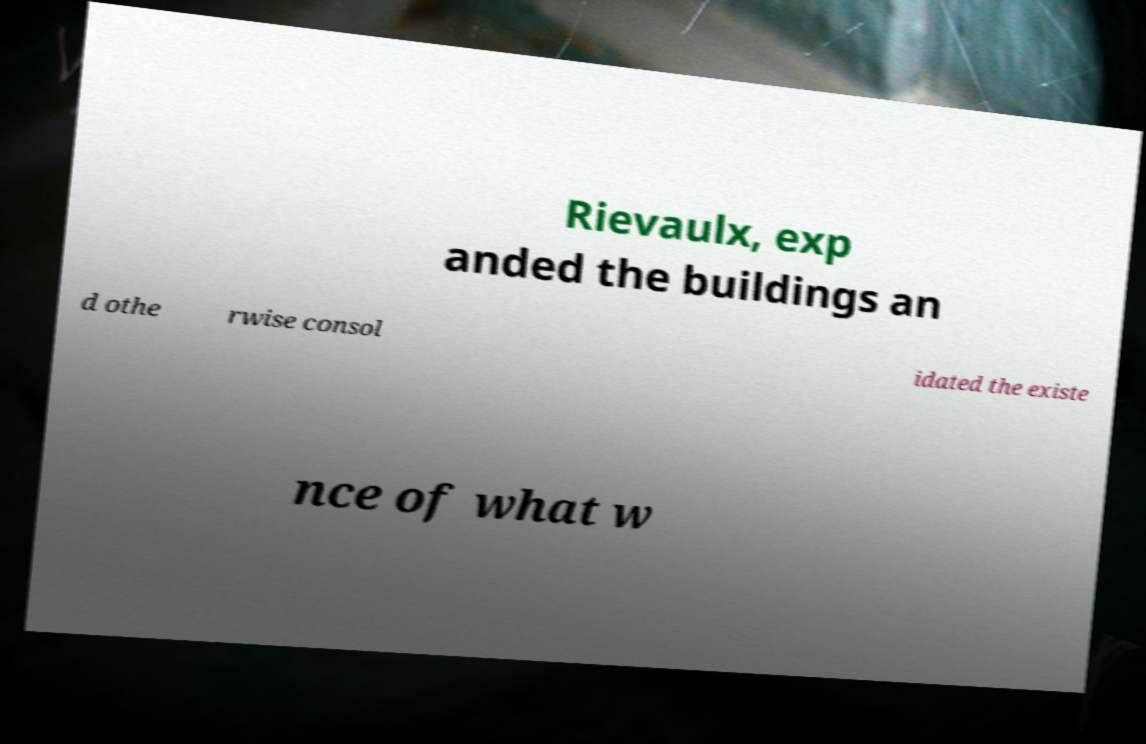Could you assist in decoding the text presented in this image and type it out clearly? Rievaulx, exp anded the buildings an d othe rwise consol idated the existe nce of what w 